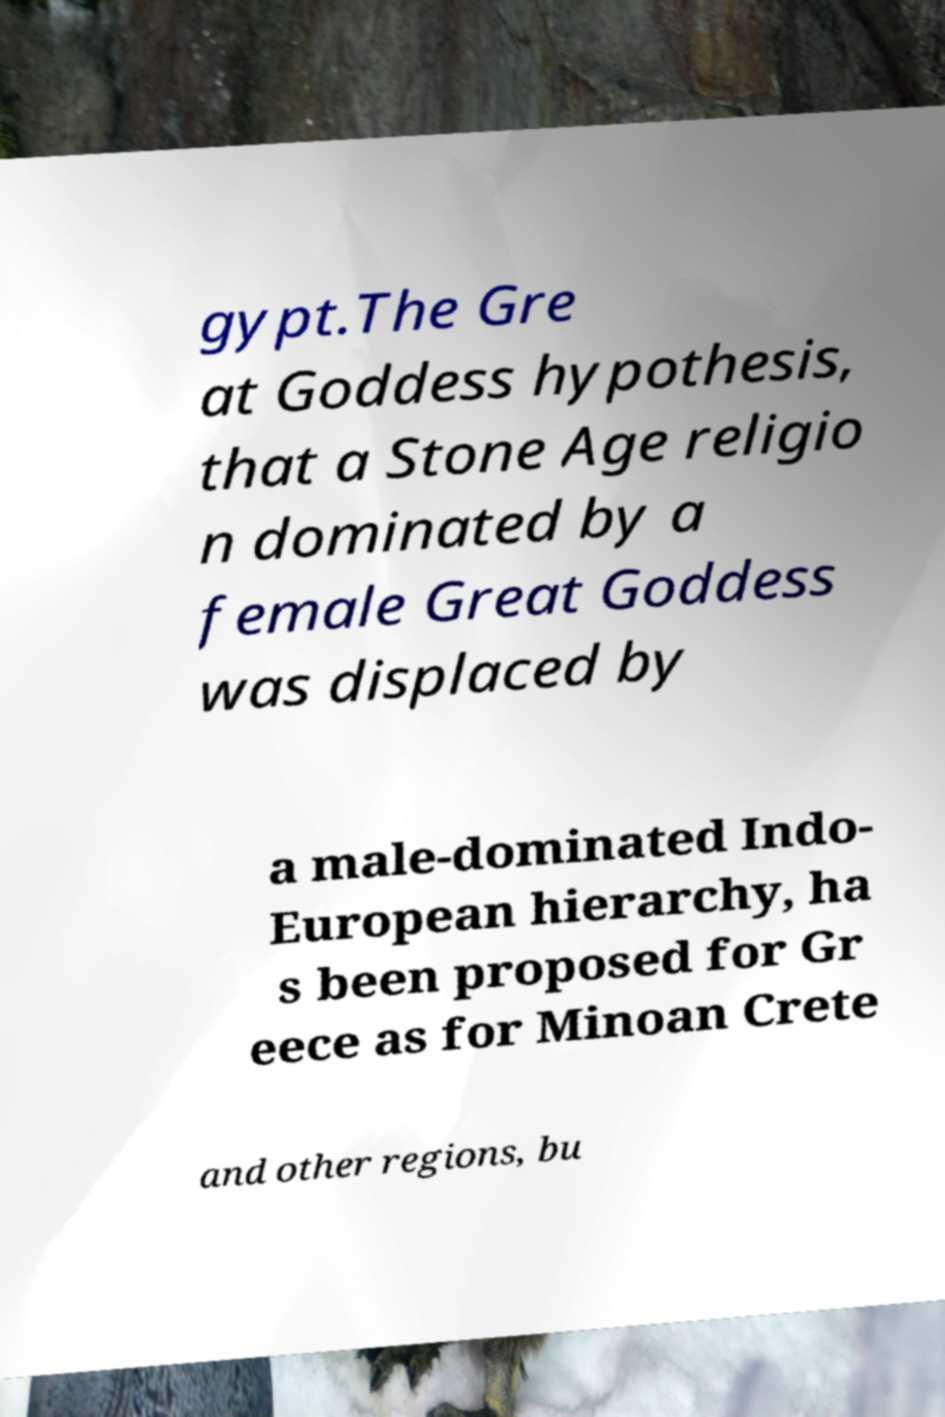Could you extract and type out the text from this image? gypt.The Gre at Goddess hypothesis, that a Stone Age religio n dominated by a female Great Goddess was displaced by a male-dominated Indo- European hierarchy, ha s been proposed for Gr eece as for Minoan Crete and other regions, bu 